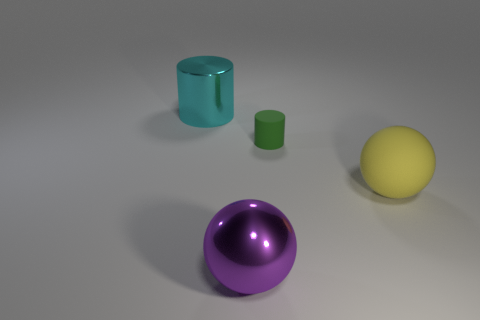What number of other large shiny balls have the same color as the big shiny sphere?
Your answer should be very brief. 0. There is a metal object behind the large sphere behind the big shiny object that is in front of the cyan thing; what is its size?
Ensure brevity in your answer.  Large. What number of rubber objects are either large balls or large purple spheres?
Provide a succinct answer. 1. There is a small green thing; is its shape the same as the rubber thing in front of the tiny green cylinder?
Your answer should be very brief. No. Are there more metal cylinders that are right of the big matte sphere than cyan metal cylinders in front of the green matte cylinder?
Your answer should be compact. No. Are there any small rubber cylinders right of the large shiny object that is behind the ball on the right side of the small cylinder?
Give a very brief answer. Yes. Is the shape of the big object behind the large matte thing the same as  the tiny rubber object?
Your response must be concise. Yes. Is the number of metal objects that are behind the big cyan object less than the number of large things that are behind the big purple sphere?
Offer a very short reply. Yes. What is the material of the big yellow sphere?
Keep it short and to the point. Rubber. There is a yellow rubber sphere; what number of large objects are in front of it?
Ensure brevity in your answer.  1. 